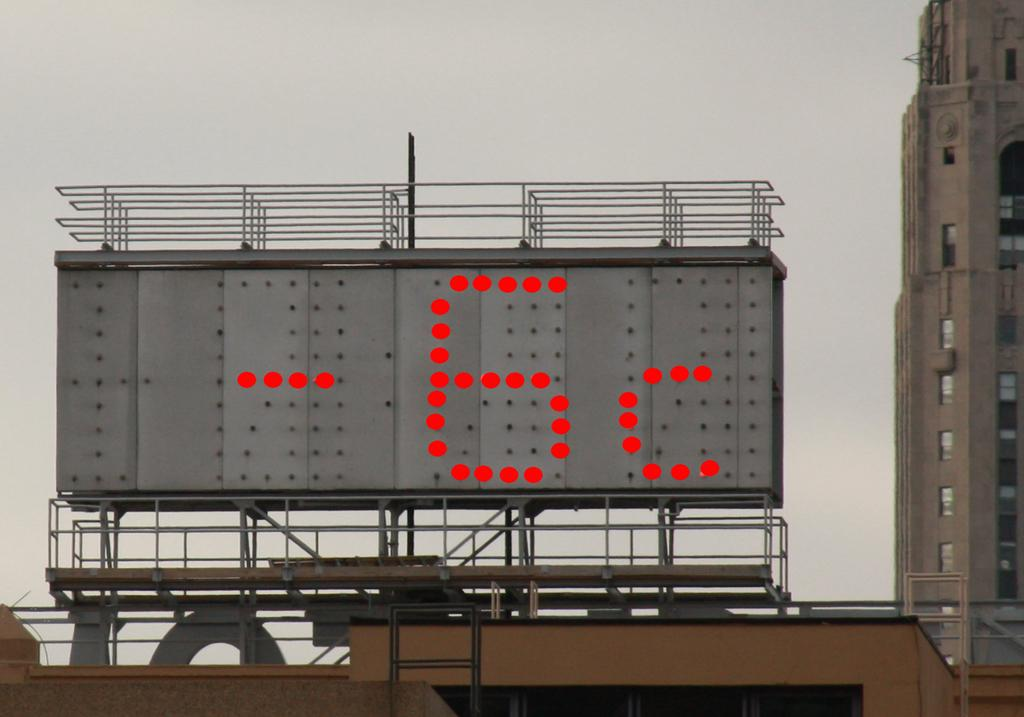Provide a one-sentence caption for the provided image. A Giant billboard shows current Temperature as -6c. 